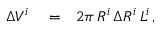Convert formula to latex. <formula><loc_0><loc_0><loc_500><loc_500>\begin{array} { r l r } { \Delta V ^ { i } } & = } & { 2 \pi \, R ^ { i } \, \Delta R ^ { i } \, L ^ { i } \, , } \end{array}</formula> 